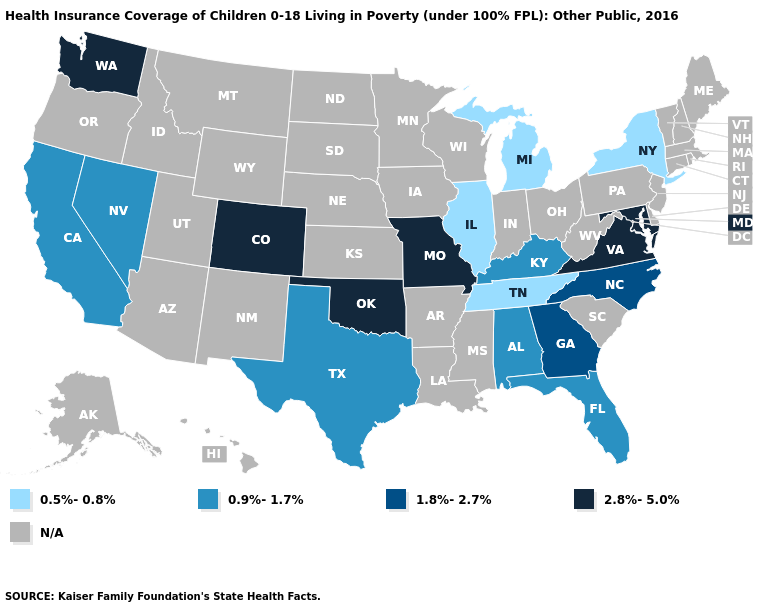What is the value of Pennsylvania?
Short answer required. N/A. What is the value of Alaska?
Write a very short answer. N/A. What is the value of Michigan?
Keep it brief. 0.5%-0.8%. Does Tennessee have the highest value in the USA?
Short answer required. No. How many symbols are there in the legend?
Be succinct. 5. What is the value of Pennsylvania?
Give a very brief answer. N/A. What is the value of Kentucky?
Quick response, please. 0.9%-1.7%. What is the value of Utah?
Short answer required. N/A. What is the value of Indiana?
Write a very short answer. N/A. What is the value of Tennessee?
Keep it brief. 0.5%-0.8%. Does Oklahoma have the highest value in the South?
Answer briefly. Yes. What is the lowest value in the South?
Be succinct. 0.5%-0.8%. What is the value of South Carolina?
Keep it brief. N/A. Name the states that have a value in the range N/A?
Write a very short answer. Alaska, Arizona, Arkansas, Connecticut, Delaware, Hawaii, Idaho, Indiana, Iowa, Kansas, Louisiana, Maine, Massachusetts, Minnesota, Mississippi, Montana, Nebraska, New Hampshire, New Jersey, New Mexico, North Dakota, Ohio, Oregon, Pennsylvania, Rhode Island, South Carolina, South Dakota, Utah, Vermont, West Virginia, Wisconsin, Wyoming. What is the highest value in states that border Wyoming?
Write a very short answer. 2.8%-5.0%. 